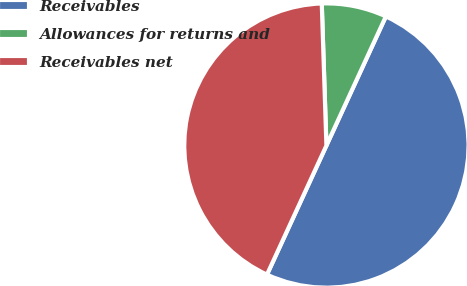Convert chart. <chart><loc_0><loc_0><loc_500><loc_500><pie_chart><fcel>Receivables<fcel>Allowances for returns and<fcel>Receivables net<nl><fcel>50.0%<fcel>7.39%<fcel>42.61%<nl></chart> 